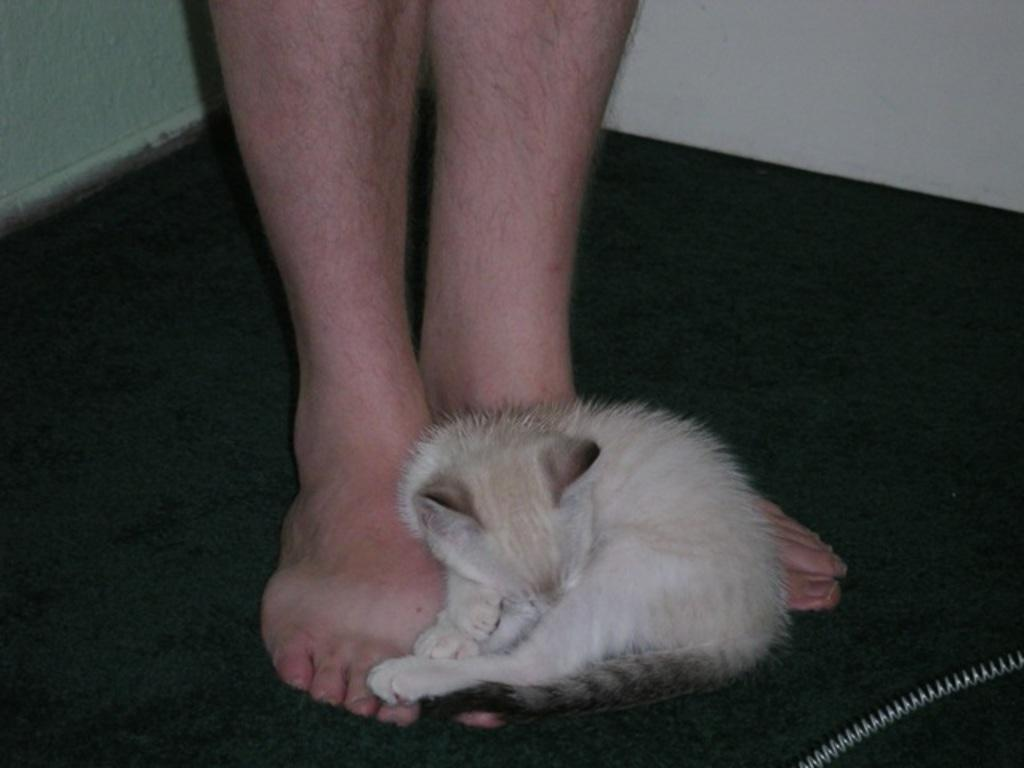What type of animal is in the image? There is a cat in the image. Can you describe the cat's position in relation to the person? The cat is in front of a person. What colors can be seen on the cat? The cat has a white and cream color. What color is the background wall in the image? The background wall is white. What type of fear is the cat experiencing in the image? There is no indication of fear in the image; the cat appears to be in a normal, relaxed state. 